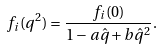Convert formula to latex. <formula><loc_0><loc_0><loc_500><loc_500>f _ { i } ( q ^ { 2 } ) = \frac { f _ { i } ( 0 ) } { 1 - a \hat { q } + b \hat { q } ^ { 2 } } .</formula> 